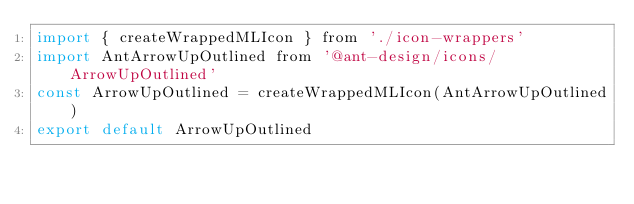Convert code to text. <code><loc_0><loc_0><loc_500><loc_500><_JavaScript_>import { createWrappedMLIcon } from './icon-wrappers'
import AntArrowUpOutlined from '@ant-design/icons/ArrowUpOutlined'
const ArrowUpOutlined = createWrappedMLIcon(AntArrowUpOutlined)
export default ArrowUpOutlined
</code> 